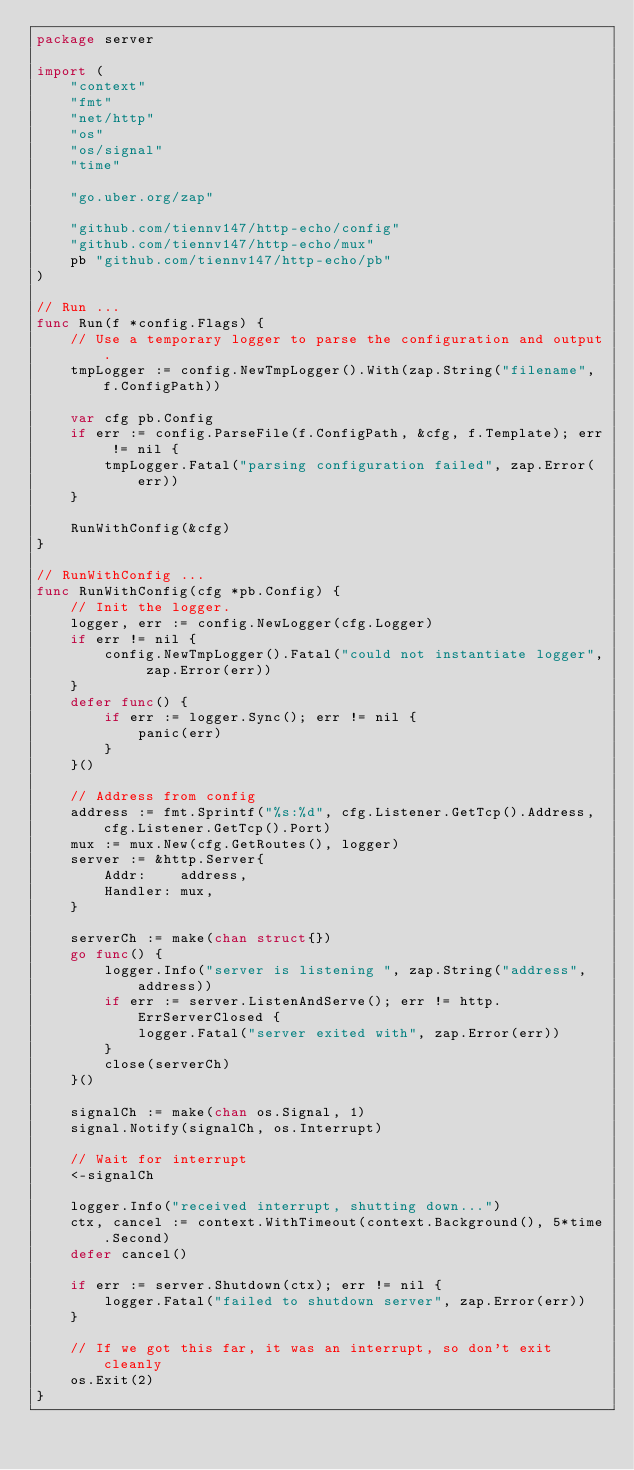Convert code to text. <code><loc_0><loc_0><loc_500><loc_500><_Go_>package server

import (
	"context"
	"fmt"
	"net/http"
	"os"
	"os/signal"
	"time"

	"go.uber.org/zap"

	"github.com/tiennv147/http-echo/config"
	"github.com/tiennv147/http-echo/mux"
	pb "github.com/tiennv147/http-echo/pb"
)

// Run ...
func Run(f *config.Flags) {
	// Use a temporary logger to parse the configuration and output.
	tmpLogger := config.NewTmpLogger().With(zap.String("filename", f.ConfigPath))

	var cfg pb.Config
	if err := config.ParseFile(f.ConfigPath, &cfg, f.Template); err != nil {
		tmpLogger.Fatal("parsing configuration failed", zap.Error(err))
	}

	RunWithConfig(&cfg)
}

// RunWithConfig ...
func RunWithConfig(cfg *pb.Config) {
	// Init the logger.
	logger, err := config.NewLogger(cfg.Logger)
	if err != nil {
		config.NewTmpLogger().Fatal("could not instantiate logger", zap.Error(err))
	}
	defer func() {
		if err := logger.Sync(); err != nil {
			panic(err)
		}
	}()

	// Address from config
	address := fmt.Sprintf("%s:%d", cfg.Listener.GetTcp().Address, cfg.Listener.GetTcp().Port)
	mux := mux.New(cfg.GetRoutes(), logger)
	server := &http.Server{
		Addr:    address,
		Handler: mux,
	}

	serverCh := make(chan struct{})
	go func() {
		logger.Info("server is listening ", zap.String("address", address))
		if err := server.ListenAndServe(); err != http.ErrServerClosed {
			logger.Fatal("server exited with", zap.Error(err))
		}
		close(serverCh)
	}()

	signalCh := make(chan os.Signal, 1)
	signal.Notify(signalCh, os.Interrupt)

	// Wait for interrupt
	<-signalCh

	logger.Info("received interrupt, shutting down...")
	ctx, cancel := context.WithTimeout(context.Background(), 5*time.Second)
	defer cancel()

	if err := server.Shutdown(ctx); err != nil {
		logger.Fatal("failed to shutdown server", zap.Error(err))
	}

	// If we got this far, it was an interrupt, so don't exit cleanly
	os.Exit(2)
}
</code> 